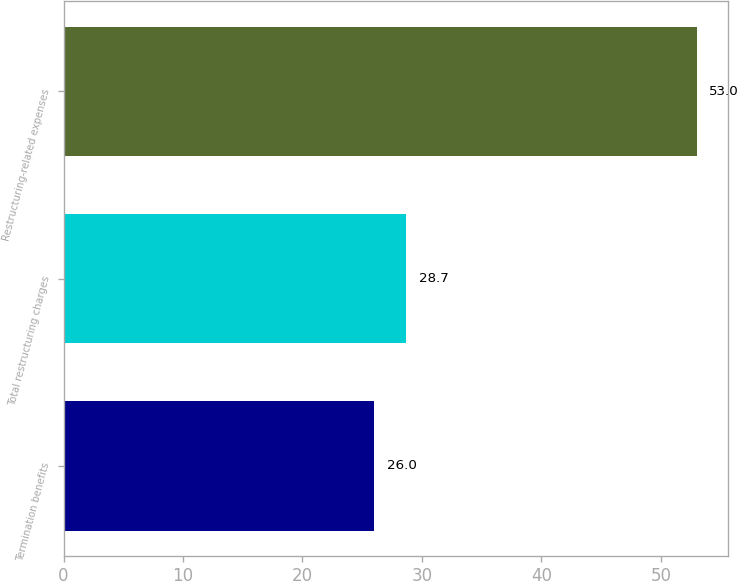Convert chart to OTSL. <chart><loc_0><loc_0><loc_500><loc_500><bar_chart><fcel>Termination benefits<fcel>Total restructuring charges<fcel>Restructuring-related expenses<nl><fcel>26<fcel>28.7<fcel>53<nl></chart> 